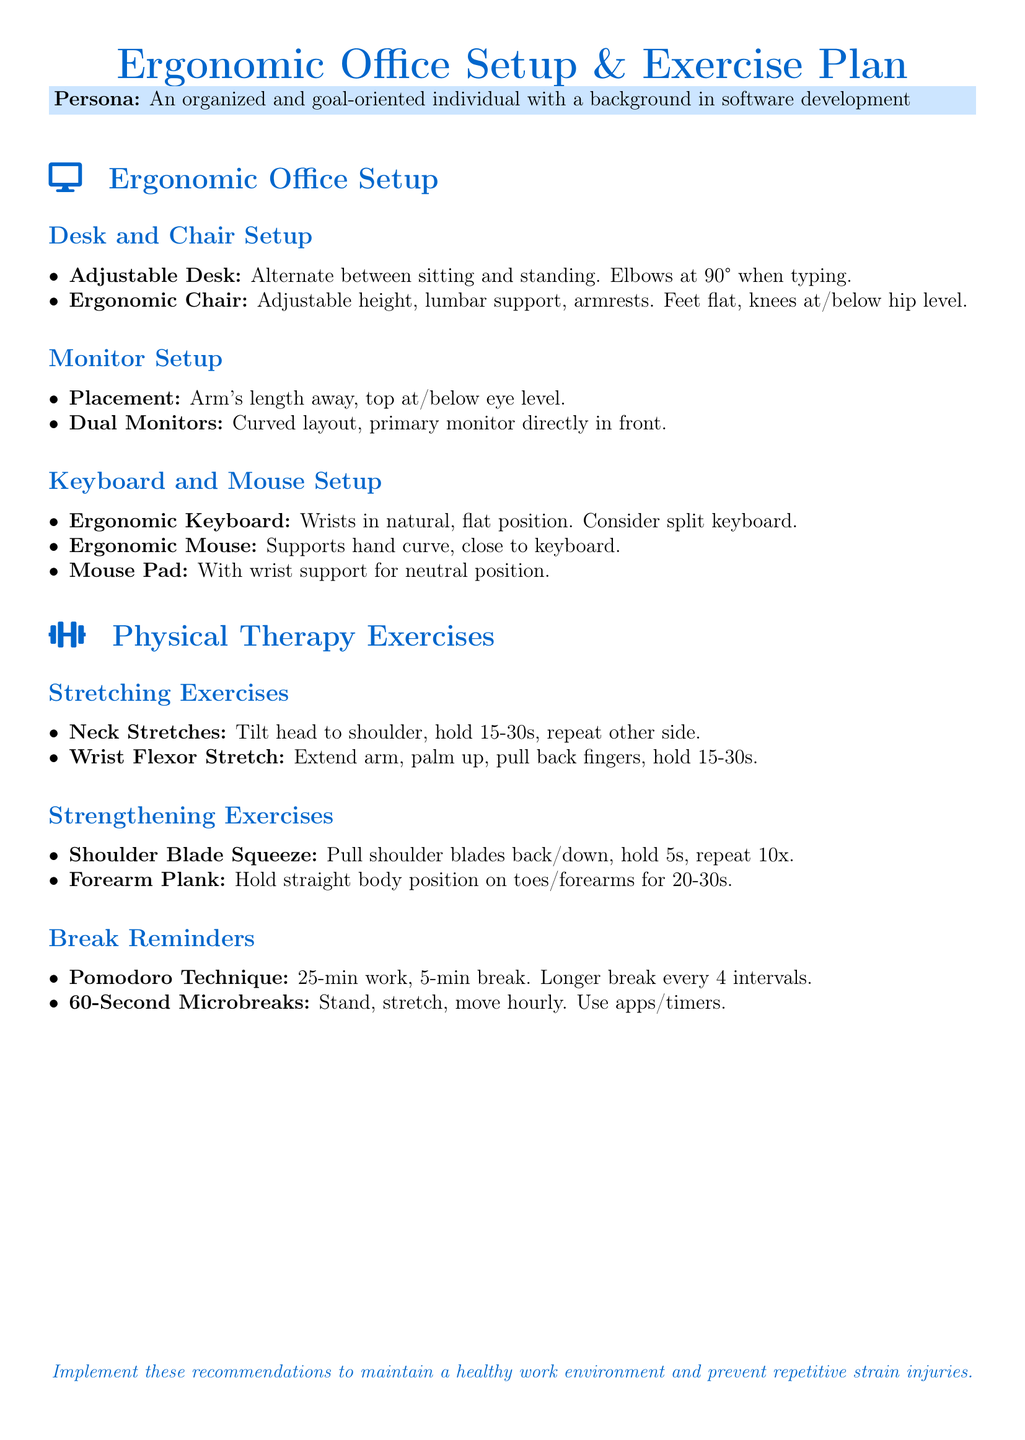What is the title of the document? The title of the document is centered at the top and indicates the main subject of the content.
Answer: Ergonomic Office Setup & Exercise Plan What ergonomic feature should an adjustable desk provide? The document specifies that one of the requirements for an adjustable desk is to allow alternation between sitting and standing.
Answer: Alternate between sitting and standing How far should the monitor be placed from the eyes? The document clearly mentions the preferred distance for monitor placement, which helps in maintaining good ergonomics.
Answer: Arm's length away What exercise requires holding the body straight on toes and forearms? The exercise is stated in the strengthening exercises section and outlines a specific position for improving core stability.
Answer: Forearm Plank What technique is recommended for break timing? The document introduces a specific method for managing work intervals and breaks, which supports productivity and well-being.
Answer: Pomodoro Technique How long should neck stretches be held? The duration for holding the neck stretch is explicitly mentioned in the stretching exercise instructions.
Answer: 15-30 seconds What should be ensured for the wrist when using an ergonomic keyboard? This aspect is highlighted as essential for maintaining wrist health while typing, as described in the keyboard setup.
Answer: Natural, flat position How often should microbreaks be taken? The document suggests a specific frequency for taking short breaks during work hours to promote movement and reduce strain.
Answer: Hourly 